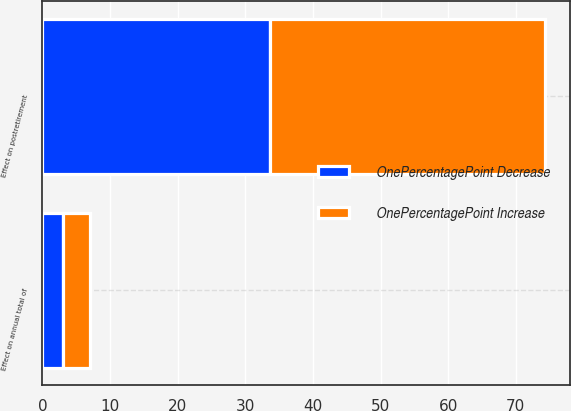<chart> <loc_0><loc_0><loc_500><loc_500><stacked_bar_chart><ecel><fcel>Effect on annual total of<fcel>Effect on postretirement<nl><fcel>OnePercentagePoint Increase<fcel>4<fcel>40.7<nl><fcel>OnePercentagePoint Decrease<fcel>3<fcel>33.6<nl></chart> 